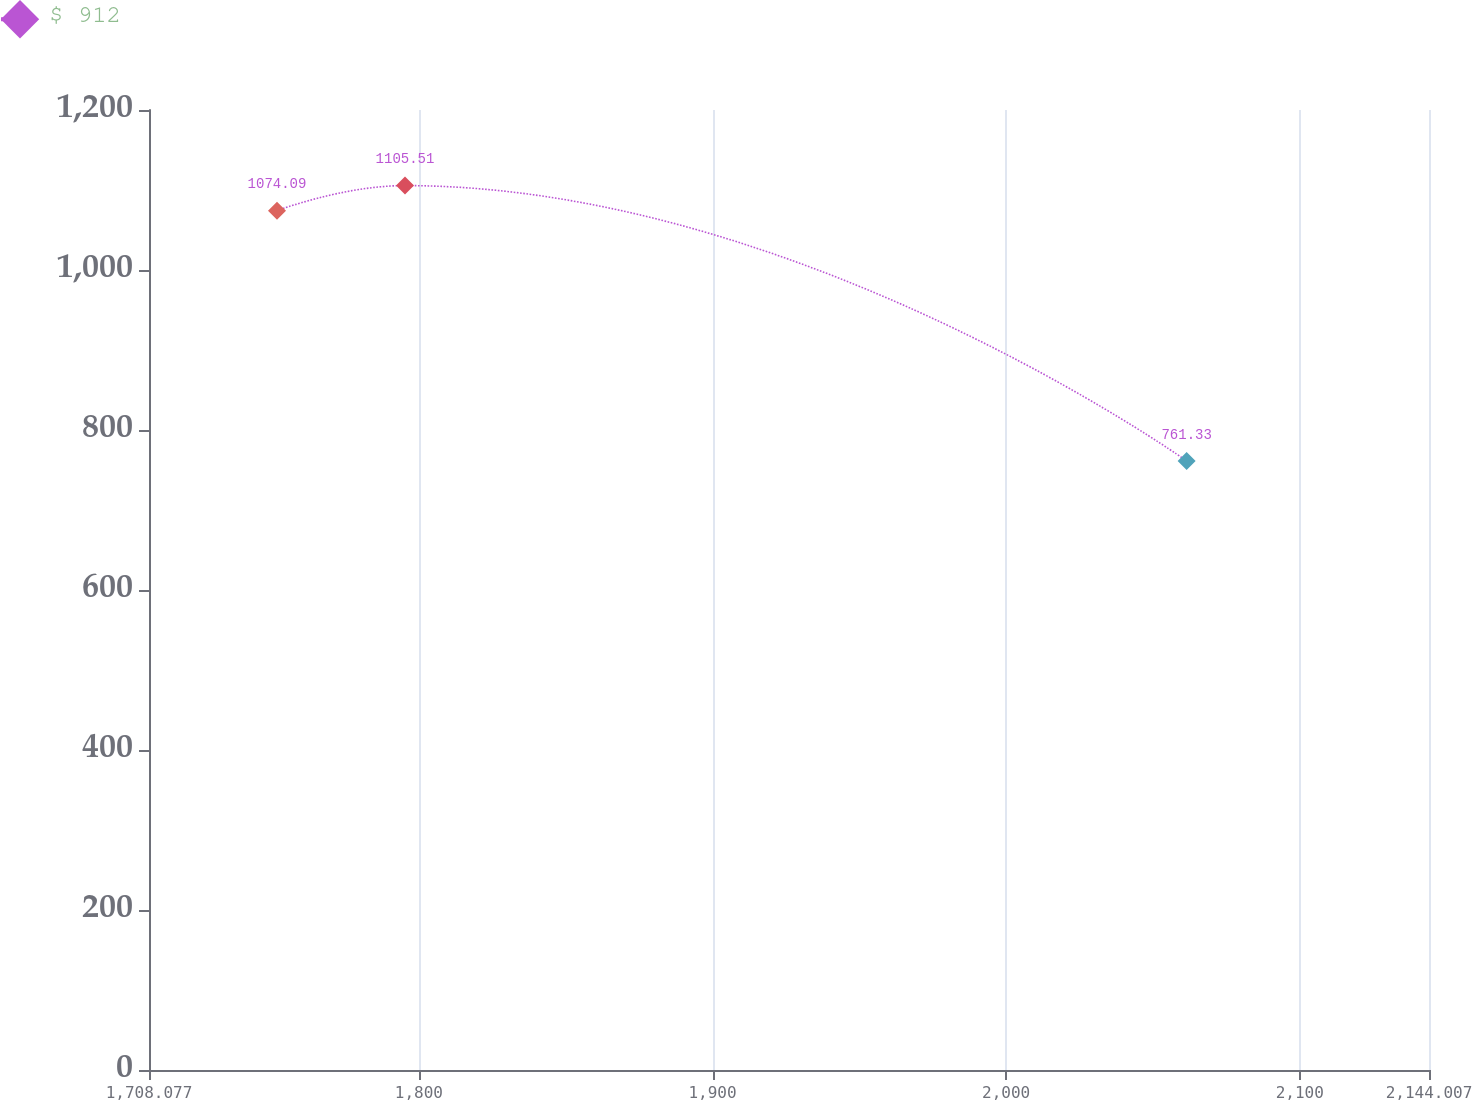Convert chart to OTSL. <chart><loc_0><loc_0><loc_500><loc_500><line_chart><ecel><fcel>$ 912<nl><fcel>1751.67<fcel>1074.09<nl><fcel>1795.26<fcel>1105.51<nl><fcel>2061.47<fcel>761.33<nl><fcel>2187.6<fcel>820.32<nl></chart> 